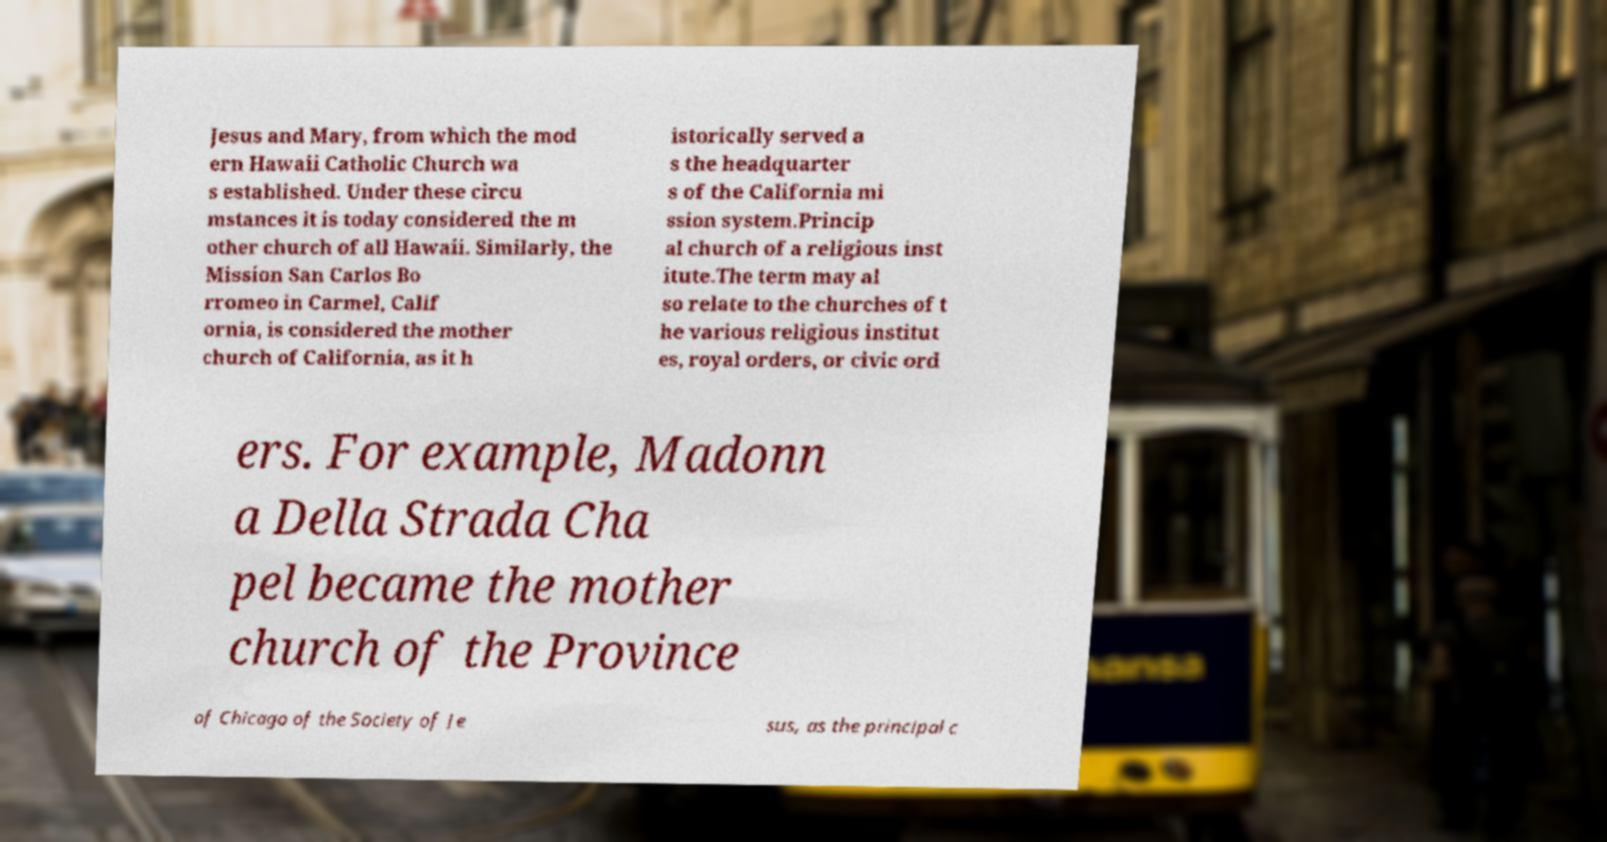Can you read and provide the text displayed in the image?This photo seems to have some interesting text. Can you extract and type it out for me? Jesus and Mary, from which the mod ern Hawaii Catholic Church wa s established. Under these circu mstances it is today considered the m other church of all Hawaii. Similarly, the Mission San Carlos Bo rromeo in Carmel, Calif ornia, is considered the mother church of California, as it h istorically served a s the headquarter s of the California mi ssion system.Princip al church of a religious inst itute.The term may al so relate to the churches of t he various religious institut es, royal orders, or civic ord ers. For example, Madonn a Della Strada Cha pel became the mother church of the Province of Chicago of the Society of Je sus, as the principal c 